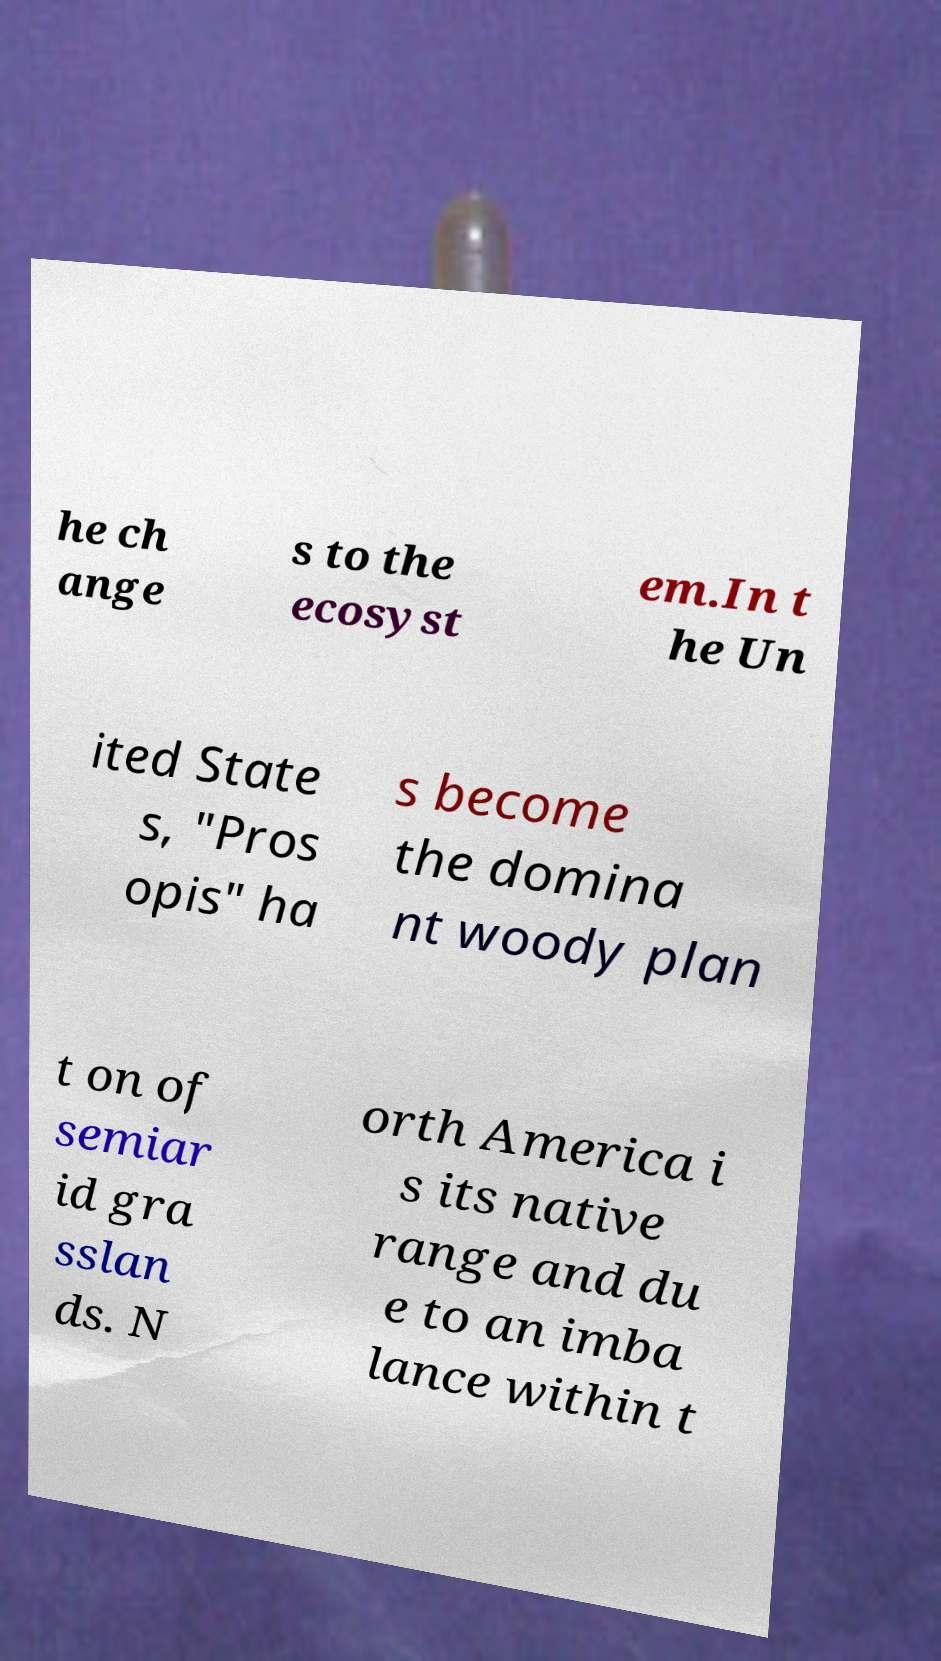I need the written content from this picture converted into text. Can you do that? he ch ange s to the ecosyst em.In t he Un ited State s, "Pros opis" ha s become the domina nt woody plan t on of semiar id gra sslan ds. N orth America i s its native range and du e to an imba lance within t 